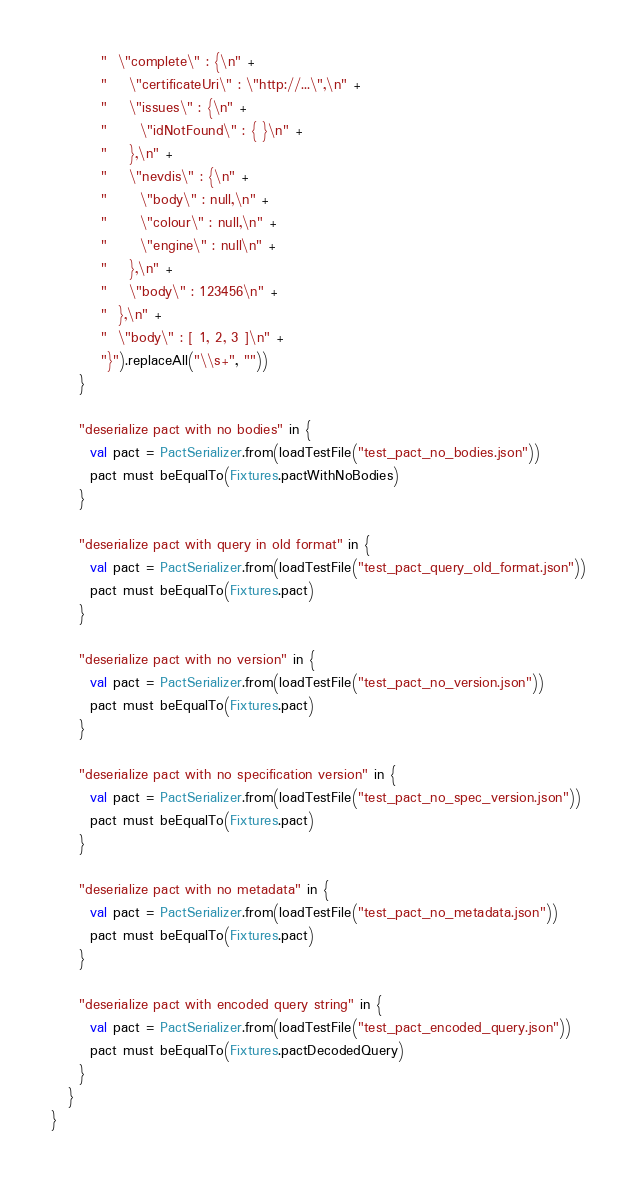Convert code to text. <code><loc_0><loc_0><loc_500><loc_500><_Scala_>         "  \"complete\" : {\n" +
         "    \"certificateUri\" : \"http://...\",\n" +
         "    \"issues\" : {\n" +
         "      \"idNotFound\" : { }\n" +
         "    },\n" +
         "    \"nevdis\" : {\n" +
         "      \"body\" : null,\n" +
         "      \"colour\" : null,\n" +
         "      \"engine\" : null\n" +
         "    },\n" +
         "    \"body\" : 123456\n" +
         "  },\n" +
         "  \"body\" : [ 1, 2, 3 ]\n" +
         "}").replaceAll("\\s+", ""))
     }

     "deserialize pact with no bodies" in {
       val pact = PactSerializer.from(loadTestFile("test_pact_no_bodies.json"))
       pact must beEqualTo(Fixtures.pactWithNoBodies)
     }

     "deserialize pact with query in old format" in {
       val pact = PactSerializer.from(loadTestFile("test_pact_query_old_format.json"))
       pact must beEqualTo(Fixtures.pact)
     }

     "deserialize pact with no version" in {
       val pact = PactSerializer.from(loadTestFile("test_pact_no_version.json"))
       pact must beEqualTo(Fixtures.pact)
     }

     "deserialize pact with no specification version" in {
       val pact = PactSerializer.from(loadTestFile("test_pact_no_spec_version.json"))
       pact must beEqualTo(Fixtures.pact)
     }

     "deserialize pact with no metadata" in {
       val pact = PactSerializer.from(loadTestFile("test_pact_no_metadata.json"))
       pact must beEqualTo(Fixtures.pact)
     }

     "deserialize pact with encoded query string" in {
       val pact = PactSerializer.from(loadTestFile("test_pact_encoded_query.json"))
       pact must beEqualTo(Fixtures.pactDecodedQuery)
     }
   }
}
</code> 